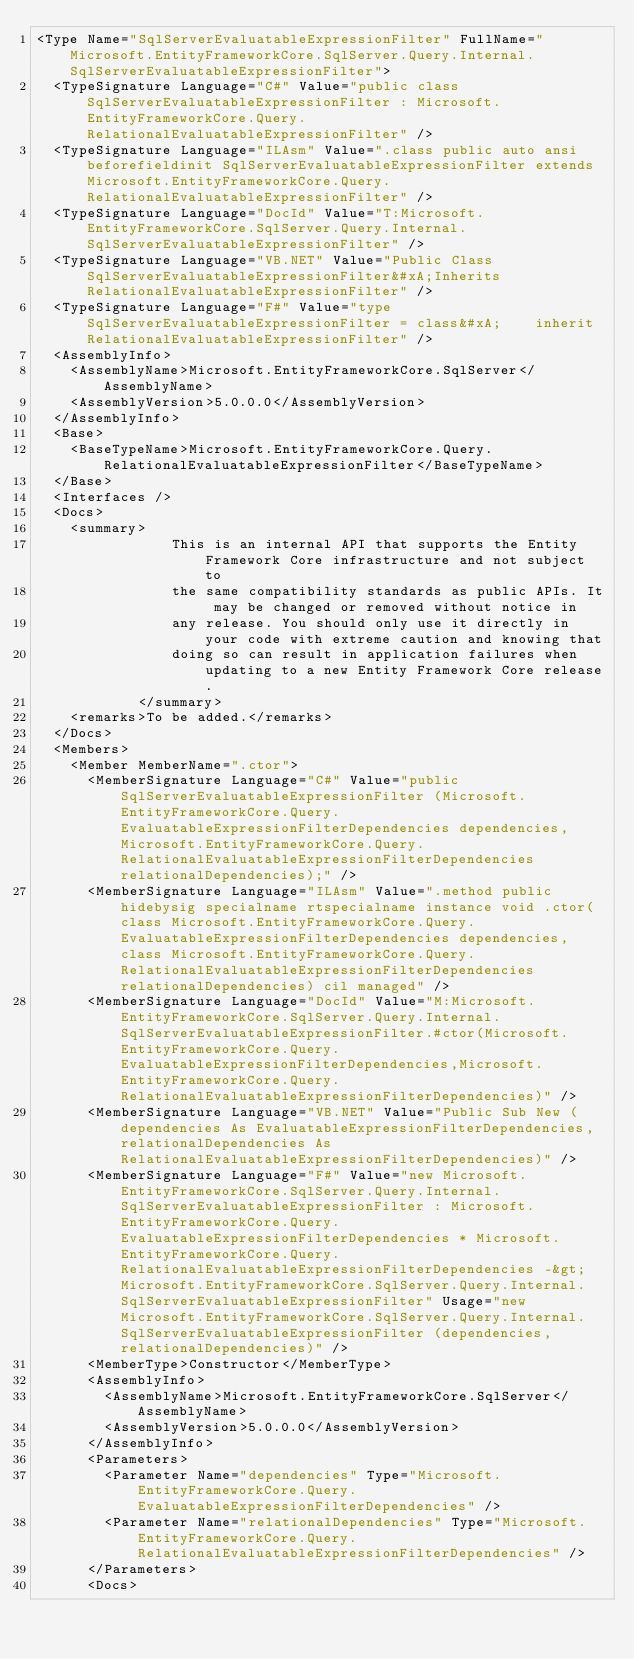Convert code to text. <code><loc_0><loc_0><loc_500><loc_500><_XML_><Type Name="SqlServerEvaluatableExpressionFilter" FullName="Microsoft.EntityFrameworkCore.SqlServer.Query.Internal.SqlServerEvaluatableExpressionFilter">
  <TypeSignature Language="C#" Value="public class SqlServerEvaluatableExpressionFilter : Microsoft.EntityFrameworkCore.Query.RelationalEvaluatableExpressionFilter" />
  <TypeSignature Language="ILAsm" Value=".class public auto ansi beforefieldinit SqlServerEvaluatableExpressionFilter extends Microsoft.EntityFrameworkCore.Query.RelationalEvaluatableExpressionFilter" />
  <TypeSignature Language="DocId" Value="T:Microsoft.EntityFrameworkCore.SqlServer.Query.Internal.SqlServerEvaluatableExpressionFilter" />
  <TypeSignature Language="VB.NET" Value="Public Class SqlServerEvaluatableExpressionFilter&#xA;Inherits RelationalEvaluatableExpressionFilter" />
  <TypeSignature Language="F#" Value="type SqlServerEvaluatableExpressionFilter = class&#xA;    inherit RelationalEvaluatableExpressionFilter" />
  <AssemblyInfo>
    <AssemblyName>Microsoft.EntityFrameworkCore.SqlServer</AssemblyName>
    <AssemblyVersion>5.0.0.0</AssemblyVersion>
  </AssemblyInfo>
  <Base>
    <BaseTypeName>Microsoft.EntityFrameworkCore.Query.RelationalEvaluatableExpressionFilter</BaseTypeName>
  </Base>
  <Interfaces />
  <Docs>
    <summary>
                This is an internal API that supports the Entity Framework Core infrastructure and not subject to
                the same compatibility standards as public APIs. It may be changed or removed without notice in
                any release. You should only use it directly in your code with extreme caution and knowing that
                doing so can result in application failures when updating to a new Entity Framework Core release.
            </summary>
    <remarks>To be added.</remarks>
  </Docs>
  <Members>
    <Member MemberName=".ctor">
      <MemberSignature Language="C#" Value="public SqlServerEvaluatableExpressionFilter (Microsoft.EntityFrameworkCore.Query.EvaluatableExpressionFilterDependencies dependencies, Microsoft.EntityFrameworkCore.Query.RelationalEvaluatableExpressionFilterDependencies relationalDependencies);" />
      <MemberSignature Language="ILAsm" Value=".method public hidebysig specialname rtspecialname instance void .ctor(class Microsoft.EntityFrameworkCore.Query.EvaluatableExpressionFilterDependencies dependencies, class Microsoft.EntityFrameworkCore.Query.RelationalEvaluatableExpressionFilterDependencies relationalDependencies) cil managed" />
      <MemberSignature Language="DocId" Value="M:Microsoft.EntityFrameworkCore.SqlServer.Query.Internal.SqlServerEvaluatableExpressionFilter.#ctor(Microsoft.EntityFrameworkCore.Query.EvaluatableExpressionFilterDependencies,Microsoft.EntityFrameworkCore.Query.RelationalEvaluatableExpressionFilterDependencies)" />
      <MemberSignature Language="VB.NET" Value="Public Sub New (dependencies As EvaluatableExpressionFilterDependencies, relationalDependencies As RelationalEvaluatableExpressionFilterDependencies)" />
      <MemberSignature Language="F#" Value="new Microsoft.EntityFrameworkCore.SqlServer.Query.Internal.SqlServerEvaluatableExpressionFilter : Microsoft.EntityFrameworkCore.Query.EvaluatableExpressionFilterDependencies * Microsoft.EntityFrameworkCore.Query.RelationalEvaluatableExpressionFilterDependencies -&gt; Microsoft.EntityFrameworkCore.SqlServer.Query.Internal.SqlServerEvaluatableExpressionFilter" Usage="new Microsoft.EntityFrameworkCore.SqlServer.Query.Internal.SqlServerEvaluatableExpressionFilter (dependencies, relationalDependencies)" />
      <MemberType>Constructor</MemberType>
      <AssemblyInfo>
        <AssemblyName>Microsoft.EntityFrameworkCore.SqlServer</AssemblyName>
        <AssemblyVersion>5.0.0.0</AssemblyVersion>
      </AssemblyInfo>
      <Parameters>
        <Parameter Name="dependencies" Type="Microsoft.EntityFrameworkCore.Query.EvaluatableExpressionFilterDependencies" />
        <Parameter Name="relationalDependencies" Type="Microsoft.EntityFrameworkCore.Query.RelationalEvaluatableExpressionFilterDependencies" />
      </Parameters>
      <Docs></code> 